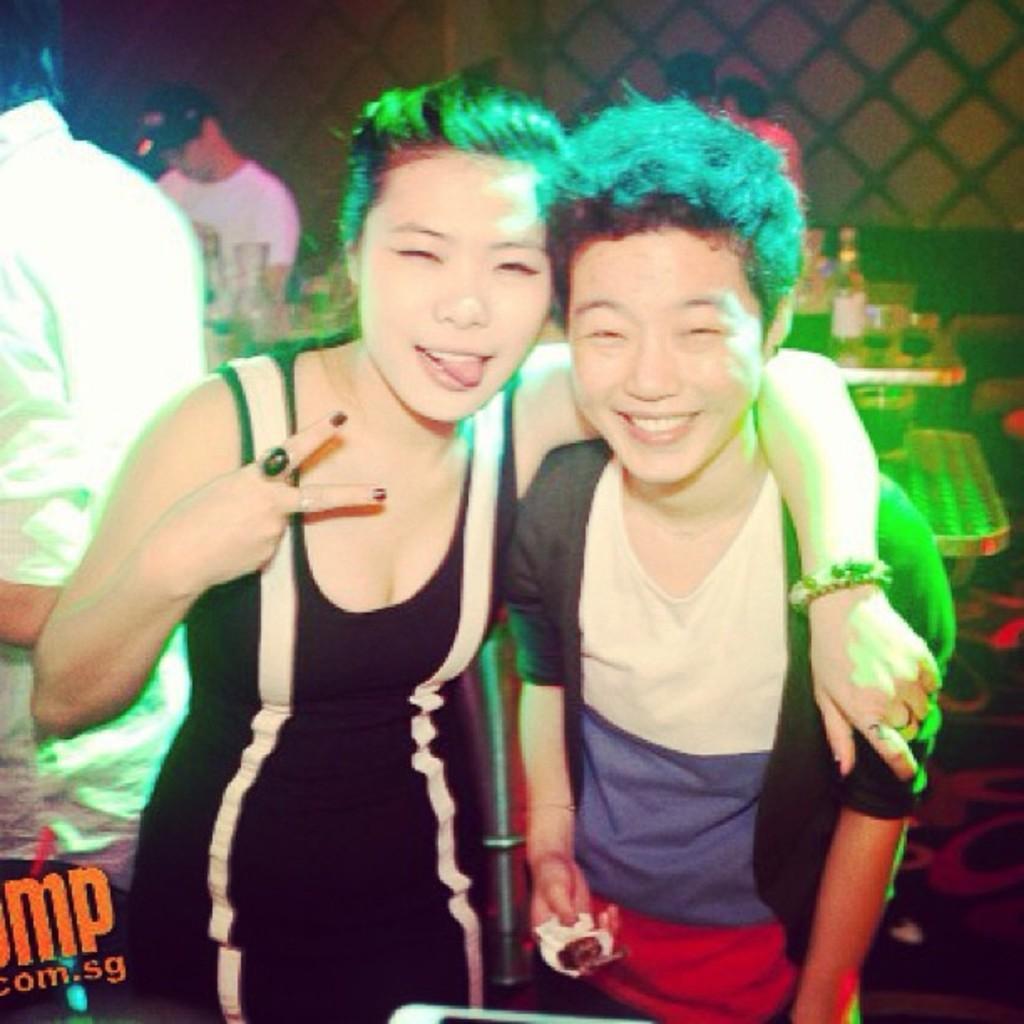Please provide a concise description of this image. In this image we can see persons standing on the floor and one of them is holding an object in the hands. In the background we can see a table on which beverage bottles, cutlery and crockery are placed. In the background we can see walls. 